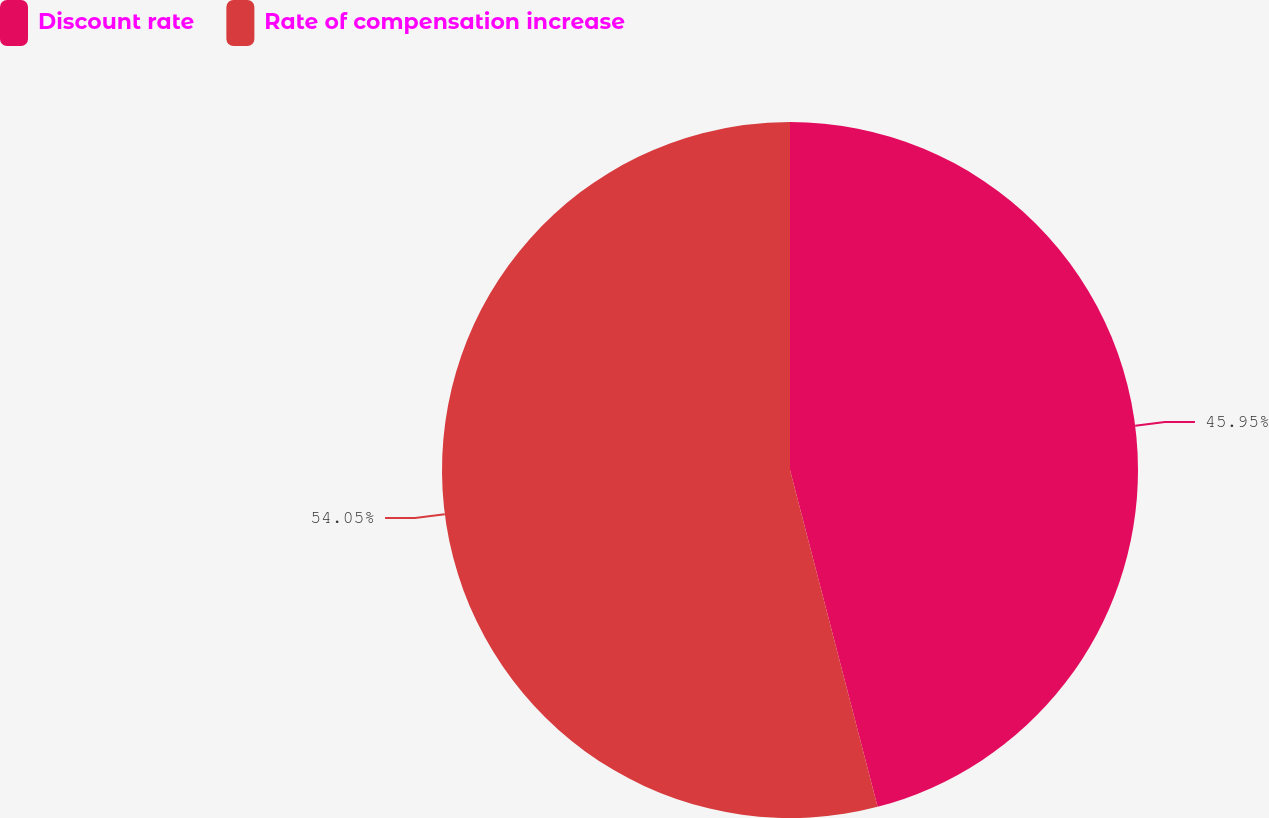Convert chart. <chart><loc_0><loc_0><loc_500><loc_500><pie_chart><fcel>Discount rate<fcel>Rate of compensation increase<nl><fcel>45.95%<fcel>54.05%<nl></chart> 